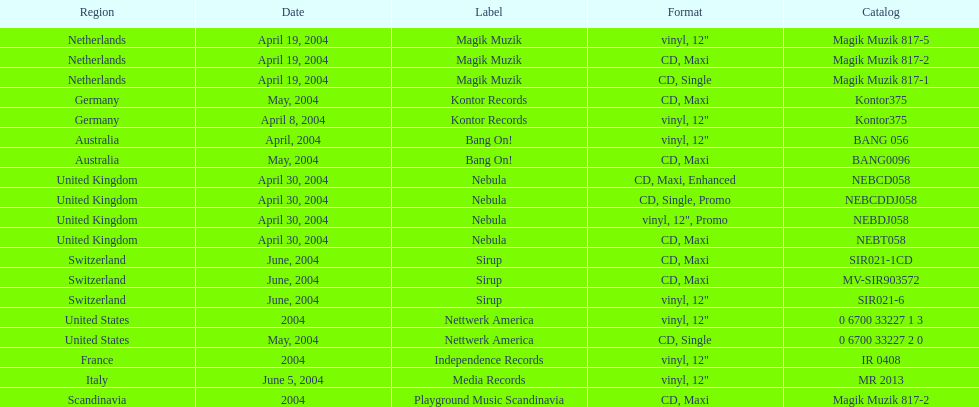What region is above australia? Germany. 